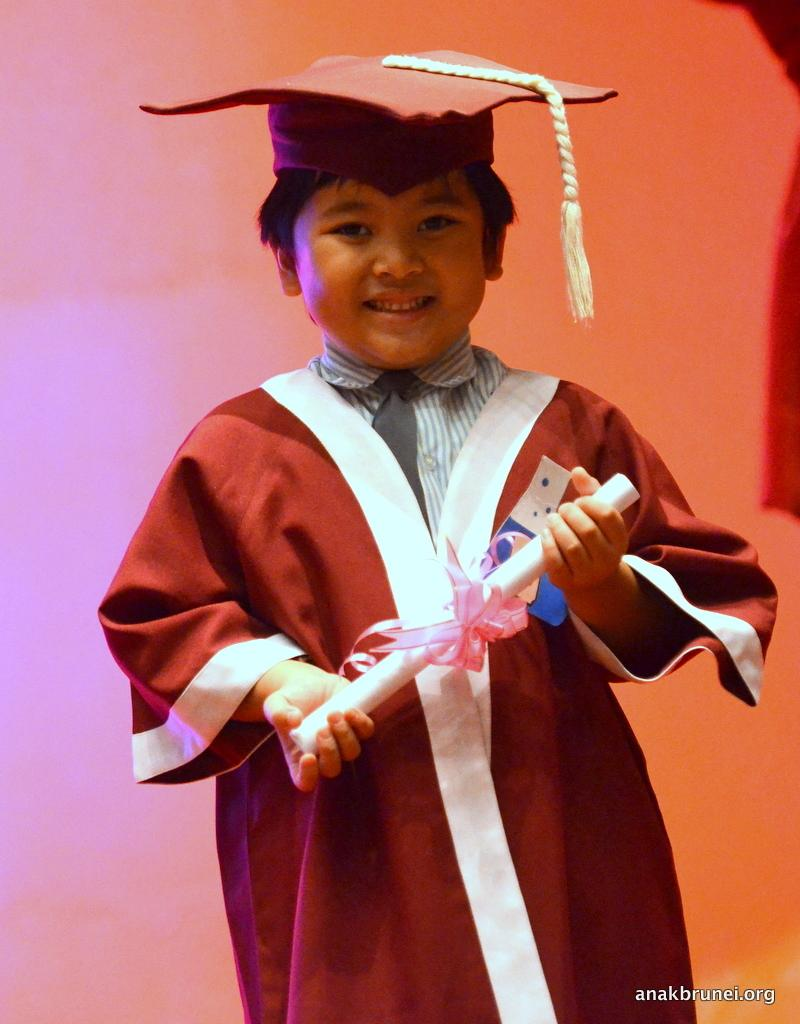Who is the main subject in the image? There is a boy in the image. What is the boy holding in the image? The boy is holding a paper with a ribbon. What is the boy wearing on his head? The boy is wearing a cap. What is attached to the cap? There is a rope on the cap. What can be seen in the background of the image? There is a wall in the background of the image. Can you describe any additional features of the image? There is a watermark in the right corner of the image. What type of shoe is the actor wearing in the image? There is no actor or shoe present in the image; it features a boy holding a paper with a ribbon. How does the boy's stomach feel in the image? The image does not provide any information about the boy's stomach or how he might be feeling. 